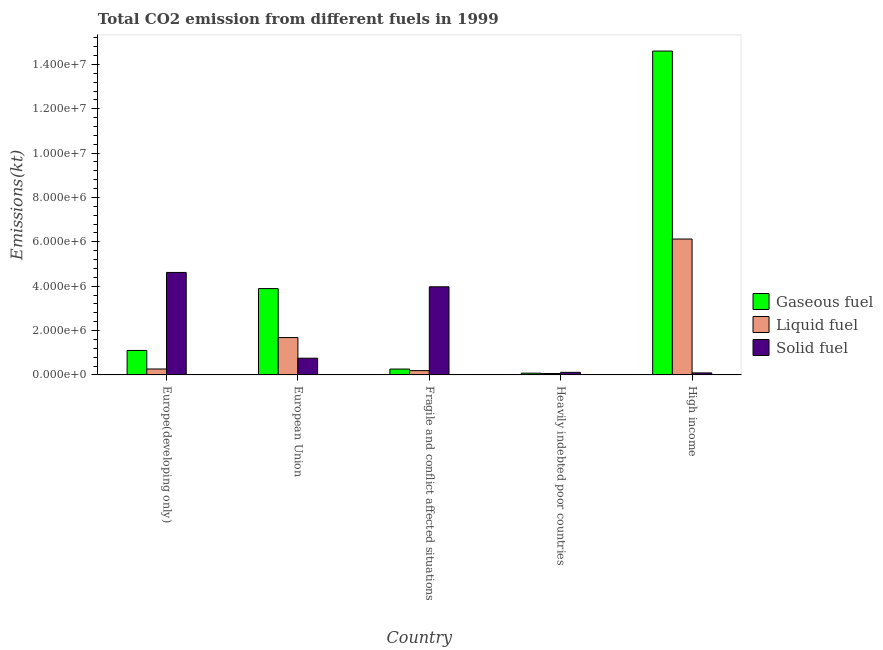How many different coloured bars are there?
Provide a short and direct response. 3. How many groups of bars are there?
Your response must be concise. 5. What is the label of the 3rd group of bars from the left?
Your response must be concise. Fragile and conflict affected situations. What is the amount of co2 emissions from gaseous fuel in High income?
Your answer should be very brief. 1.46e+07. Across all countries, what is the maximum amount of co2 emissions from solid fuel?
Give a very brief answer. 4.62e+06. Across all countries, what is the minimum amount of co2 emissions from solid fuel?
Make the answer very short. 9.04e+04. In which country was the amount of co2 emissions from gaseous fuel maximum?
Make the answer very short. High income. In which country was the amount of co2 emissions from gaseous fuel minimum?
Make the answer very short. Heavily indebted poor countries. What is the total amount of co2 emissions from liquid fuel in the graph?
Your answer should be very brief. 8.34e+06. What is the difference between the amount of co2 emissions from gaseous fuel in Europe(developing only) and that in Heavily indebted poor countries?
Your answer should be compact. 1.03e+06. What is the difference between the amount of co2 emissions from solid fuel in European Union and the amount of co2 emissions from liquid fuel in Heavily indebted poor countries?
Your response must be concise. 6.89e+05. What is the average amount of co2 emissions from solid fuel per country?
Give a very brief answer. 1.91e+06. What is the difference between the amount of co2 emissions from liquid fuel and amount of co2 emissions from solid fuel in European Union?
Provide a short and direct response. 9.31e+05. In how many countries, is the amount of co2 emissions from gaseous fuel greater than 11600000 kt?
Make the answer very short. 1. What is the ratio of the amount of co2 emissions from liquid fuel in Fragile and conflict affected situations to that in High income?
Offer a very short reply. 0.03. What is the difference between the highest and the second highest amount of co2 emissions from solid fuel?
Ensure brevity in your answer.  6.48e+05. What is the difference between the highest and the lowest amount of co2 emissions from gaseous fuel?
Provide a short and direct response. 1.45e+07. In how many countries, is the amount of co2 emissions from solid fuel greater than the average amount of co2 emissions from solid fuel taken over all countries?
Your answer should be compact. 2. Is the sum of the amount of co2 emissions from liquid fuel in Europe(developing only) and Heavily indebted poor countries greater than the maximum amount of co2 emissions from solid fuel across all countries?
Give a very brief answer. No. What does the 3rd bar from the left in High income represents?
Make the answer very short. Solid fuel. What does the 1st bar from the right in High income represents?
Keep it short and to the point. Solid fuel. Is it the case that in every country, the sum of the amount of co2 emissions from gaseous fuel and amount of co2 emissions from liquid fuel is greater than the amount of co2 emissions from solid fuel?
Ensure brevity in your answer.  No. Are all the bars in the graph horizontal?
Provide a short and direct response. No. How many countries are there in the graph?
Your answer should be very brief. 5. What is the difference between two consecutive major ticks on the Y-axis?
Your answer should be compact. 2.00e+06. Are the values on the major ticks of Y-axis written in scientific E-notation?
Offer a terse response. Yes. Does the graph contain grids?
Your answer should be very brief. No. Where does the legend appear in the graph?
Offer a very short reply. Center right. How many legend labels are there?
Offer a very short reply. 3. How are the legend labels stacked?
Offer a terse response. Vertical. What is the title of the graph?
Your answer should be very brief. Total CO2 emission from different fuels in 1999. What is the label or title of the X-axis?
Provide a short and direct response. Country. What is the label or title of the Y-axis?
Offer a terse response. Emissions(kt). What is the Emissions(kt) in Gaseous fuel in Europe(developing only)?
Your answer should be very brief. 1.10e+06. What is the Emissions(kt) in Liquid fuel in Europe(developing only)?
Your response must be concise. 2.67e+05. What is the Emissions(kt) of Solid fuel in Europe(developing only)?
Provide a succinct answer. 4.62e+06. What is the Emissions(kt) of Gaseous fuel in European Union?
Give a very brief answer. 3.89e+06. What is the Emissions(kt) in Liquid fuel in European Union?
Provide a succinct answer. 1.68e+06. What is the Emissions(kt) of Solid fuel in European Union?
Keep it short and to the point. 7.53e+05. What is the Emissions(kt) of Gaseous fuel in Fragile and conflict affected situations?
Provide a short and direct response. 2.63e+05. What is the Emissions(kt) in Liquid fuel in Fragile and conflict affected situations?
Your response must be concise. 1.94e+05. What is the Emissions(kt) of Solid fuel in Fragile and conflict affected situations?
Provide a short and direct response. 3.97e+06. What is the Emissions(kt) in Gaseous fuel in Heavily indebted poor countries?
Your answer should be compact. 7.81e+04. What is the Emissions(kt) of Liquid fuel in Heavily indebted poor countries?
Your response must be concise. 6.38e+04. What is the Emissions(kt) of Solid fuel in Heavily indebted poor countries?
Make the answer very short. 1.15e+05. What is the Emissions(kt) of Gaseous fuel in High income?
Your answer should be very brief. 1.46e+07. What is the Emissions(kt) of Liquid fuel in High income?
Make the answer very short. 6.13e+06. What is the Emissions(kt) of Solid fuel in High income?
Ensure brevity in your answer.  9.04e+04. Across all countries, what is the maximum Emissions(kt) of Gaseous fuel?
Your answer should be very brief. 1.46e+07. Across all countries, what is the maximum Emissions(kt) of Liquid fuel?
Provide a short and direct response. 6.13e+06. Across all countries, what is the maximum Emissions(kt) in Solid fuel?
Keep it short and to the point. 4.62e+06. Across all countries, what is the minimum Emissions(kt) of Gaseous fuel?
Keep it short and to the point. 7.81e+04. Across all countries, what is the minimum Emissions(kt) of Liquid fuel?
Ensure brevity in your answer.  6.38e+04. Across all countries, what is the minimum Emissions(kt) of Solid fuel?
Make the answer very short. 9.04e+04. What is the total Emissions(kt) of Gaseous fuel in the graph?
Your response must be concise. 1.99e+07. What is the total Emissions(kt) of Liquid fuel in the graph?
Keep it short and to the point. 8.34e+06. What is the total Emissions(kt) of Solid fuel in the graph?
Give a very brief answer. 9.55e+06. What is the difference between the Emissions(kt) of Gaseous fuel in Europe(developing only) and that in European Union?
Your response must be concise. -2.79e+06. What is the difference between the Emissions(kt) in Liquid fuel in Europe(developing only) and that in European Union?
Ensure brevity in your answer.  -1.42e+06. What is the difference between the Emissions(kt) of Solid fuel in Europe(developing only) and that in European Union?
Make the answer very short. 3.87e+06. What is the difference between the Emissions(kt) of Gaseous fuel in Europe(developing only) and that in Fragile and conflict affected situations?
Keep it short and to the point. 8.40e+05. What is the difference between the Emissions(kt) in Liquid fuel in Europe(developing only) and that in Fragile and conflict affected situations?
Ensure brevity in your answer.  7.34e+04. What is the difference between the Emissions(kt) in Solid fuel in Europe(developing only) and that in Fragile and conflict affected situations?
Your answer should be compact. 6.48e+05. What is the difference between the Emissions(kt) in Gaseous fuel in Europe(developing only) and that in Heavily indebted poor countries?
Keep it short and to the point. 1.03e+06. What is the difference between the Emissions(kt) of Liquid fuel in Europe(developing only) and that in Heavily indebted poor countries?
Your answer should be compact. 2.03e+05. What is the difference between the Emissions(kt) in Solid fuel in Europe(developing only) and that in Heavily indebted poor countries?
Make the answer very short. 4.51e+06. What is the difference between the Emissions(kt) in Gaseous fuel in Europe(developing only) and that in High income?
Make the answer very short. -1.35e+07. What is the difference between the Emissions(kt) of Liquid fuel in Europe(developing only) and that in High income?
Make the answer very short. -5.86e+06. What is the difference between the Emissions(kt) of Solid fuel in Europe(developing only) and that in High income?
Your answer should be compact. 4.53e+06. What is the difference between the Emissions(kt) in Gaseous fuel in European Union and that in Fragile and conflict affected situations?
Give a very brief answer. 3.63e+06. What is the difference between the Emissions(kt) of Liquid fuel in European Union and that in Fragile and conflict affected situations?
Make the answer very short. 1.49e+06. What is the difference between the Emissions(kt) in Solid fuel in European Union and that in Fragile and conflict affected situations?
Your response must be concise. -3.22e+06. What is the difference between the Emissions(kt) in Gaseous fuel in European Union and that in Heavily indebted poor countries?
Provide a short and direct response. 3.81e+06. What is the difference between the Emissions(kt) of Liquid fuel in European Union and that in Heavily indebted poor countries?
Your response must be concise. 1.62e+06. What is the difference between the Emissions(kt) in Solid fuel in European Union and that in Heavily indebted poor countries?
Your answer should be very brief. 6.38e+05. What is the difference between the Emissions(kt) in Gaseous fuel in European Union and that in High income?
Provide a short and direct response. -1.07e+07. What is the difference between the Emissions(kt) of Liquid fuel in European Union and that in High income?
Provide a short and direct response. -4.44e+06. What is the difference between the Emissions(kt) of Solid fuel in European Union and that in High income?
Provide a short and direct response. 6.63e+05. What is the difference between the Emissions(kt) in Gaseous fuel in Fragile and conflict affected situations and that in Heavily indebted poor countries?
Your answer should be very brief. 1.85e+05. What is the difference between the Emissions(kt) in Liquid fuel in Fragile and conflict affected situations and that in Heavily indebted poor countries?
Ensure brevity in your answer.  1.30e+05. What is the difference between the Emissions(kt) of Solid fuel in Fragile and conflict affected situations and that in Heavily indebted poor countries?
Your answer should be compact. 3.86e+06. What is the difference between the Emissions(kt) of Gaseous fuel in Fragile and conflict affected situations and that in High income?
Give a very brief answer. -1.43e+07. What is the difference between the Emissions(kt) of Liquid fuel in Fragile and conflict affected situations and that in High income?
Your answer should be compact. -5.93e+06. What is the difference between the Emissions(kt) of Solid fuel in Fragile and conflict affected situations and that in High income?
Your answer should be compact. 3.88e+06. What is the difference between the Emissions(kt) of Gaseous fuel in Heavily indebted poor countries and that in High income?
Provide a short and direct response. -1.45e+07. What is the difference between the Emissions(kt) in Liquid fuel in Heavily indebted poor countries and that in High income?
Make the answer very short. -6.06e+06. What is the difference between the Emissions(kt) of Solid fuel in Heavily indebted poor countries and that in High income?
Ensure brevity in your answer.  2.48e+04. What is the difference between the Emissions(kt) in Gaseous fuel in Europe(developing only) and the Emissions(kt) in Liquid fuel in European Union?
Offer a very short reply. -5.81e+05. What is the difference between the Emissions(kt) in Gaseous fuel in Europe(developing only) and the Emissions(kt) in Solid fuel in European Union?
Offer a very short reply. 3.50e+05. What is the difference between the Emissions(kt) of Liquid fuel in Europe(developing only) and the Emissions(kt) of Solid fuel in European Union?
Give a very brief answer. -4.86e+05. What is the difference between the Emissions(kt) in Gaseous fuel in Europe(developing only) and the Emissions(kt) in Liquid fuel in Fragile and conflict affected situations?
Your answer should be very brief. 9.10e+05. What is the difference between the Emissions(kt) in Gaseous fuel in Europe(developing only) and the Emissions(kt) in Solid fuel in Fragile and conflict affected situations?
Provide a short and direct response. -2.87e+06. What is the difference between the Emissions(kt) of Liquid fuel in Europe(developing only) and the Emissions(kt) of Solid fuel in Fragile and conflict affected situations?
Offer a very short reply. -3.71e+06. What is the difference between the Emissions(kt) in Gaseous fuel in Europe(developing only) and the Emissions(kt) in Liquid fuel in Heavily indebted poor countries?
Your answer should be compact. 1.04e+06. What is the difference between the Emissions(kt) in Gaseous fuel in Europe(developing only) and the Emissions(kt) in Solid fuel in Heavily indebted poor countries?
Keep it short and to the point. 9.88e+05. What is the difference between the Emissions(kt) of Liquid fuel in Europe(developing only) and the Emissions(kt) of Solid fuel in Heavily indebted poor countries?
Give a very brief answer. 1.52e+05. What is the difference between the Emissions(kt) in Gaseous fuel in Europe(developing only) and the Emissions(kt) in Liquid fuel in High income?
Offer a terse response. -5.02e+06. What is the difference between the Emissions(kt) in Gaseous fuel in Europe(developing only) and the Emissions(kt) in Solid fuel in High income?
Make the answer very short. 1.01e+06. What is the difference between the Emissions(kt) in Liquid fuel in Europe(developing only) and the Emissions(kt) in Solid fuel in High income?
Offer a very short reply. 1.77e+05. What is the difference between the Emissions(kt) in Gaseous fuel in European Union and the Emissions(kt) in Liquid fuel in Fragile and conflict affected situations?
Your answer should be compact. 3.70e+06. What is the difference between the Emissions(kt) in Gaseous fuel in European Union and the Emissions(kt) in Solid fuel in Fragile and conflict affected situations?
Offer a very short reply. -7.99e+04. What is the difference between the Emissions(kt) of Liquid fuel in European Union and the Emissions(kt) of Solid fuel in Fragile and conflict affected situations?
Your response must be concise. -2.29e+06. What is the difference between the Emissions(kt) in Gaseous fuel in European Union and the Emissions(kt) in Liquid fuel in Heavily indebted poor countries?
Make the answer very short. 3.83e+06. What is the difference between the Emissions(kt) of Gaseous fuel in European Union and the Emissions(kt) of Solid fuel in Heavily indebted poor countries?
Your answer should be compact. 3.78e+06. What is the difference between the Emissions(kt) of Liquid fuel in European Union and the Emissions(kt) of Solid fuel in Heavily indebted poor countries?
Provide a short and direct response. 1.57e+06. What is the difference between the Emissions(kt) in Gaseous fuel in European Union and the Emissions(kt) in Liquid fuel in High income?
Provide a succinct answer. -2.23e+06. What is the difference between the Emissions(kt) in Gaseous fuel in European Union and the Emissions(kt) in Solid fuel in High income?
Your response must be concise. 3.80e+06. What is the difference between the Emissions(kt) of Liquid fuel in European Union and the Emissions(kt) of Solid fuel in High income?
Provide a short and direct response. 1.59e+06. What is the difference between the Emissions(kt) in Gaseous fuel in Fragile and conflict affected situations and the Emissions(kt) in Liquid fuel in Heavily indebted poor countries?
Your answer should be compact. 2.00e+05. What is the difference between the Emissions(kt) in Gaseous fuel in Fragile and conflict affected situations and the Emissions(kt) in Solid fuel in Heavily indebted poor countries?
Keep it short and to the point. 1.48e+05. What is the difference between the Emissions(kt) in Liquid fuel in Fragile and conflict affected situations and the Emissions(kt) in Solid fuel in Heavily indebted poor countries?
Make the answer very short. 7.86e+04. What is the difference between the Emissions(kt) in Gaseous fuel in Fragile and conflict affected situations and the Emissions(kt) in Liquid fuel in High income?
Make the answer very short. -5.86e+06. What is the difference between the Emissions(kt) of Gaseous fuel in Fragile and conflict affected situations and the Emissions(kt) of Solid fuel in High income?
Offer a terse response. 1.73e+05. What is the difference between the Emissions(kt) of Liquid fuel in Fragile and conflict affected situations and the Emissions(kt) of Solid fuel in High income?
Your response must be concise. 1.03e+05. What is the difference between the Emissions(kt) of Gaseous fuel in Heavily indebted poor countries and the Emissions(kt) of Liquid fuel in High income?
Provide a short and direct response. -6.05e+06. What is the difference between the Emissions(kt) in Gaseous fuel in Heavily indebted poor countries and the Emissions(kt) in Solid fuel in High income?
Offer a terse response. -1.23e+04. What is the difference between the Emissions(kt) of Liquid fuel in Heavily indebted poor countries and the Emissions(kt) of Solid fuel in High income?
Your response must be concise. -2.66e+04. What is the average Emissions(kt) of Gaseous fuel per country?
Keep it short and to the point. 3.99e+06. What is the average Emissions(kt) in Liquid fuel per country?
Give a very brief answer. 1.67e+06. What is the average Emissions(kt) of Solid fuel per country?
Offer a very short reply. 1.91e+06. What is the difference between the Emissions(kt) of Gaseous fuel and Emissions(kt) of Liquid fuel in Europe(developing only)?
Make the answer very short. 8.36e+05. What is the difference between the Emissions(kt) in Gaseous fuel and Emissions(kt) in Solid fuel in Europe(developing only)?
Make the answer very short. -3.52e+06. What is the difference between the Emissions(kt) in Liquid fuel and Emissions(kt) in Solid fuel in Europe(developing only)?
Keep it short and to the point. -4.35e+06. What is the difference between the Emissions(kt) of Gaseous fuel and Emissions(kt) of Liquid fuel in European Union?
Your answer should be compact. 2.21e+06. What is the difference between the Emissions(kt) of Gaseous fuel and Emissions(kt) of Solid fuel in European Union?
Keep it short and to the point. 3.14e+06. What is the difference between the Emissions(kt) of Liquid fuel and Emissions(kt) of Solid fuel in European Union?
Your response must be concise. 9.31e+05. What is the difference between the Emissions(kt) of Gaseous fuel and Emissions(kt) of Liquid fuel in Fragile and conflict affected situations?
Provide a succinct answer. 6.97e+04. What is the difference between the Emissions(kt) of Gaseous fuel and Emissions(kt) of Solid fuel in Fragile and conflict affected situations?
Provide a succinct answer. -3.71e+06. What is the difference between the Emissions(kt) of Liquid fuel and Emissions(kt) of Solid fuel in Fragile and conflict affected situations?
Your response must be concise. -3.78e+06. What is the difference between the Emissions(kt) in Gaseous fuel and Emissions(kt) in Liquid fuel in Heavily indebted poor countries?
Your response must be concise. 1.43e+04. What is the difference between the Emissions(kt) of Gaseous fuel and Emissions(kt) of Solid fuel in Heavily indebted poor countries?
Provide a succinct answer. -3.71e+04. What is the difference between the Emissions(kt) in Liquid fuel and Emissions(kt) in Solid fuel in Heavily indebted poor countries?
Make the answer very short. -5.14e+04. What is the difference between the Emissions(kt) in Gaseous fuel and Emissions(kt) in Liquid fuel in High income?
Keep it short and to the point. 8.47e+06. What is the difference between the Emissions(kt) of Gaseous fuel and Emissions(kt) of Solid fuel in High income?
Make the answer very short. 1.45e+07. What is the difference between the Emissions(kt) of Liquid fuel and Emissions(kt) of Solid fuel in High income?
Offer a very short reply. 6.04e+06. What is the ratio of the Emissions(kt) of Gaseous fuel in Europe(developing only) to that in European Union?
Offer a terse response. 0.28. What is the ratio of the Emissions(kt) in Liquid fuel in Europe(developing only) to that in European Union?
Provide a short and direct response. 0.16. What is the ratio of the Emissions(kt) in Solid fuel in Europe(developing only) to that in European Union?
Offer a terse response. 6.13. What is the ratio of the Emissions(kt) in Gaseous fuel in Europe(developing only) to that in Fragile and conflict affected situations?
Provide a short and direct response. 4.19. What is the ratio of the Emissions(kt) of Liquid fuel in Europe(developing only) to that in Fragile and conflict affected situations?
Keep it short and to the point. 1.38. What is the ratio of the Emissions(kt) in Solid fuel in Europe(developing only) to that in Fragile and conflict affected situations?
Offer a terse response. 1.16. What is the ratio of the Emissions(kt) in Gaseous fuel in Europe(developing only) to that in Heavily indebted poor countries?
Provide a succinct answer. 14.13. What is the ratio of the Emissions(kt) in Liquid fuel in Europe(developing only) to that in Heavily indebted poor countries?
Your answer should be very brief. 4.19. What is the ratio of the Emissions(kt) of Solid fuel in Europe(developing only) to that in Heavily indebted poor countries?
Offer a terse response. 40.13. What is the ratio of the Emissions(kt) of Gaseous fuel in Europe(developing only) to that in High income?
Provide a short and direct response. 0.08. What is the ratio of the Emissions(kt) in Liquid fuel in Europe(developing only) to that in High income?
Provide a short and direct response. 0.04. What is the ratio of the Emissions(kt) of Solid fuel in Europe(developing only) to that in High income?
Provide a short and direct response. 51.12. What is the ratio of the Emissions(kt) in Gaseous fuel in European Union to that in Fragile and conflict affected situations?
Offer a very short reply. 14.77. What is the ratio of the Emissions(kt) of Liquid fuel in European Union to that in Fragile and conflict affected situations?
Provide a succinct answer. 8.69. What is the ratio of the Emissions(kt) of Solid fuel in European Union to that in Fragile and conflict affected situations?
Give a very brief answer. 0.19. What is the ratio of the Emissions(kt) of Gaseous fuel in European Union to that in Heavily indebted poor countries?
Provide a short and direct response. 49.85. What is the ratio of the Emissions(kt) of Liquid fuel in European Union to that in Heavily indebted poor countries?
Make the answer very short. 26.41. What is the ratio of the Emissions(kt) in Solid fuel in European Union to that in Heavily indebted poor countries?
Your response must be concise. 6.54. What is the ratio of the Emissions(kt) of Gaseous fuel in European Union to that in High income?
Give a very brief answer. 0.27. What is the ratio of the Emissions(kt) in Liquid fuel in European Union to that in High income?
Offer a very short reply. 0.27. What is the ratio of the Emissions(kt) of Solid fuel in European Union to that in High income?
Offer a terse response. 8.33. What is the ratio of the Emissions(kt) of Gaseous fuel in Fragile and conflict affected situations to that in Heavily indebted poor countries?
Provide a short and direct response. 3.37. What is the ratio of the Emissions(kt) of Liquid fuel in Fragile and conflict affected situations to that in Heavily indebted poor countries?
Offer a terse response. 3.04. What is the ratio of the Emissions(kt) of Solid fuel in Fragile and conflict affected situations to that in Heavily indebted poor countries?
Keep it short and to the point. 34.5. What is the ratio of the Emissions(kt) in Gaseous fuel in Fragile and conflict affected situations to that in High income?
Offer a very short reply. 0.02. What is the ratio of the Emissions(kt) in Liquid fuel in Fragile and conflict affected situations to that in High income?
Offer a terse response. 0.03. What is the ratio of the Emissions(kt) of Solid fuel in Fragile and conflict affected situations to that in High income?
Ensure brevity in your answer.  43.95. What is the ratio of the Emissions(kt) of Gaseous fuel in Heavily indebted poor countries to that in High income?
Give a very brief answer. 0.01. What is the ratio of the Emissions(kt) in Liquid fuel in Heavily indebted poor countries to that in High income?
Give a very brief answer. 0.01. What is the ratio of the Emissions(kt) in Solid fuel in Heavily indebted poor countries to that in High income?
Your answer should be very brief. 1.27. What is the difference between the highest and the second highest Emissions(kt) in Gaseous fuel?
Your answer should be very brief. 1.07e+07. What is the difference between the highest and the second highest Emissions(kt) of Liquid fuel?
Make the answer very short. 4.44e+06. What is the difference between the highest and the second highest Emissions(kt) of Solid fuel?
Provide a succinct answer. 6.48e+05. What is the difference between the highest and the lowest Emissions(kt) in Gaseous fuel?
Your response must be concise. 1.45e+07. What is the difference between the highest and the lowest Emissions(kt) of Liquid fuel?
Your answer should be very brief. 6.06e+06. What is the difference between the highest and the lowest Emissions(kt) in Solid fuel?
Offer a very short reply. 4.53e+06. 